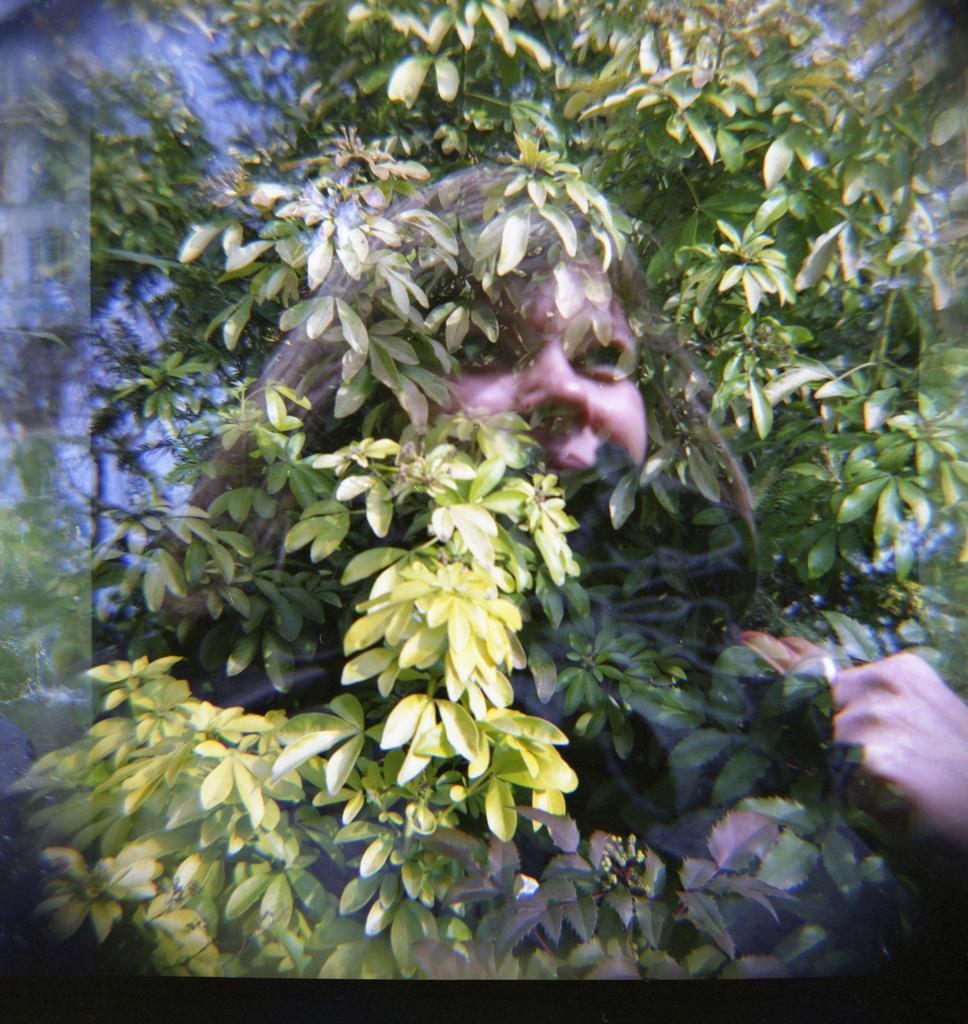Can you describe this image briefly? This looks like an edited image. I can see the face of a woman. This is a tree with branches and leaves. 